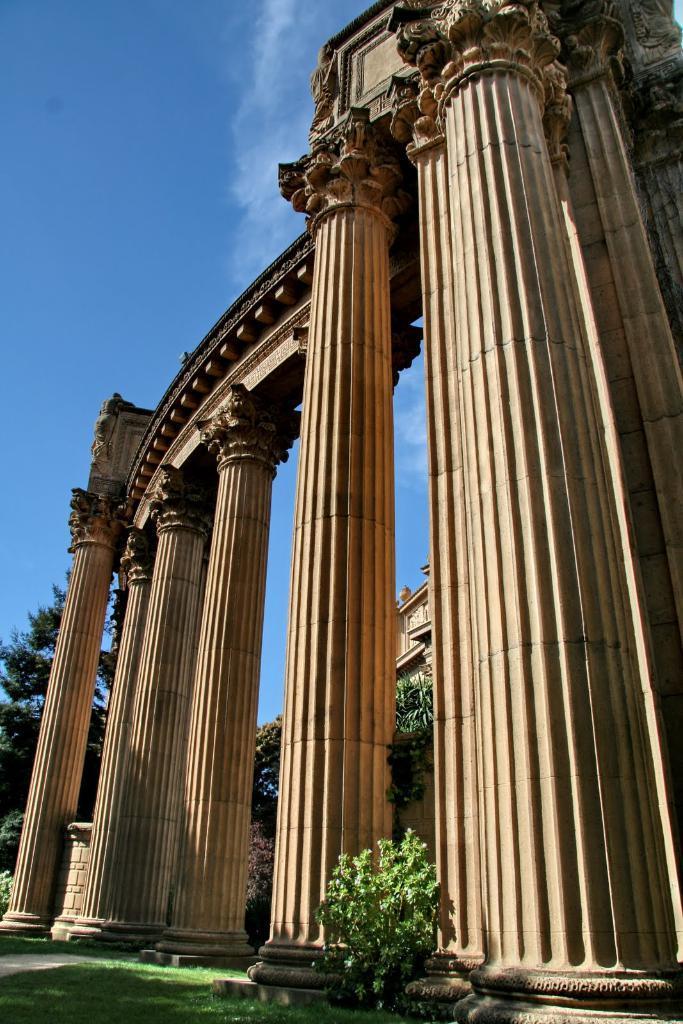In one or two sentences, can you explain what this image depicts? In this image, I can see a building and pillars. At the bottom of the image, I can see a plant and grass. In the background, there are trees and the sky. 